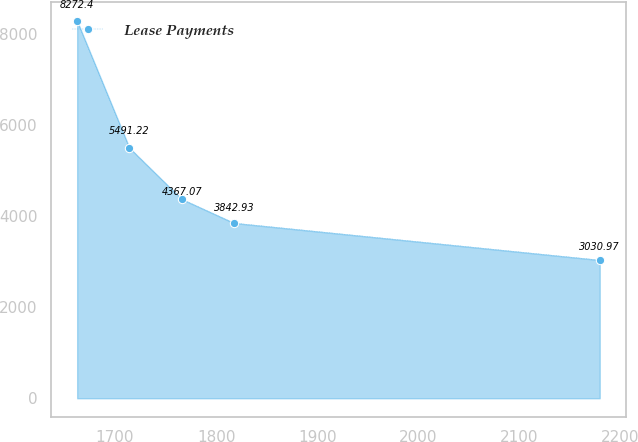Convert chart. <chart><loc_0><loc_0><loc_500><loc_500><line_chart><ecel><fcel>Lease Payments<nl><fcel>1662.58<fcel>8272.4<nl><fcel>1714.27<fcel>5491.22<nl><fcel>1765.96<fcel>4367.07<nl><fcel>1817.65<fcel>3842.93<nl><fcel>2179.44<fcel>3030.97<nl></chart> 